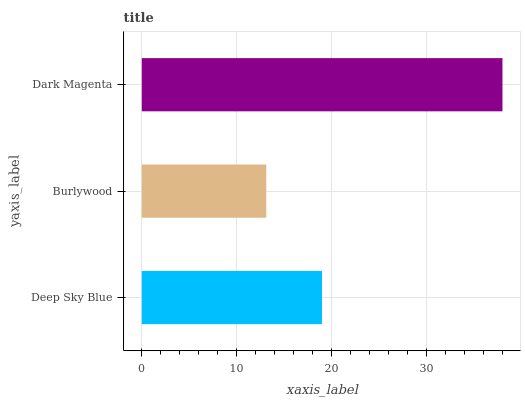Is Burlywood the minimum?
Answer yes or no. Yes. Is Dark Magenta the maximum?
Answer yes or no. Yes. Is Dark Magenta the minimum?
Answer yes or no. No. Is Burlywood the maximum?
Answer yes or no. No. Is Dark Magenta greater than Burlywood?
Answer yes or no. Yes. Is Burlywood less than Dark Magenta?
Answer yes or no. Yes. Is Burlywood greater than Dark Magenta?
Answer yes or no. No. Is Dark Magenta less than Burlywood?
Answer yes or no. No. Is Deep Sky Blue the high median?
Answer yes or no. Yes. Is Deep Sky Blue the low median?
Answer yes or no. Yes. Is Burlywood the high median?
Answer yes or no. No. Is Dark Magenta the low median?
Answer yes or no. No. 